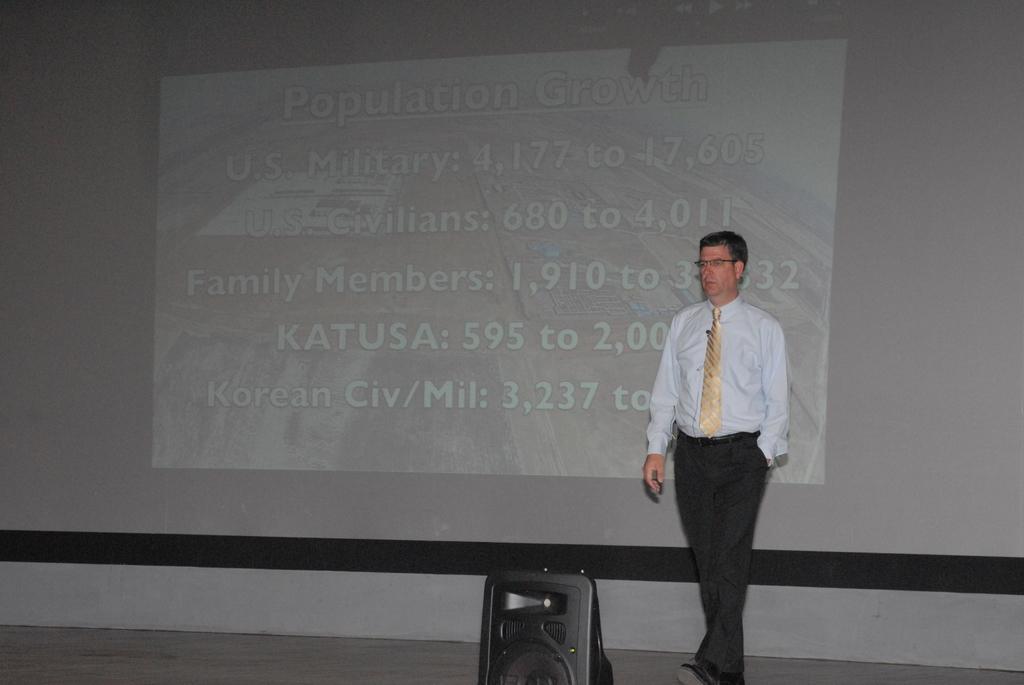Could you give a brief overview of what you see in this image? In this picture we can see a man wore a spectacle and a tie on stage and in the background we can see screen. 